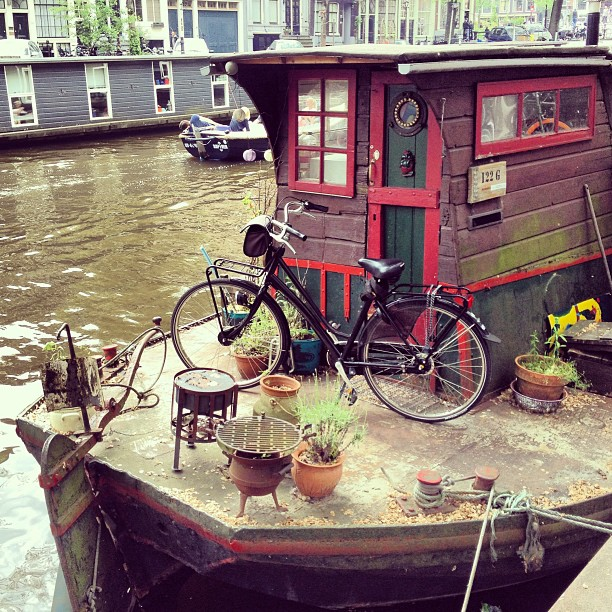Please provide a short description for this region: [0.01, 0.11, 0.06, 0.2]. The described region [0.01, 0.11, 0.06, 0.2] features a spotlessly clean, clear glass pane that reflects the serene marine setting, giving a glimpse into life aboard. 